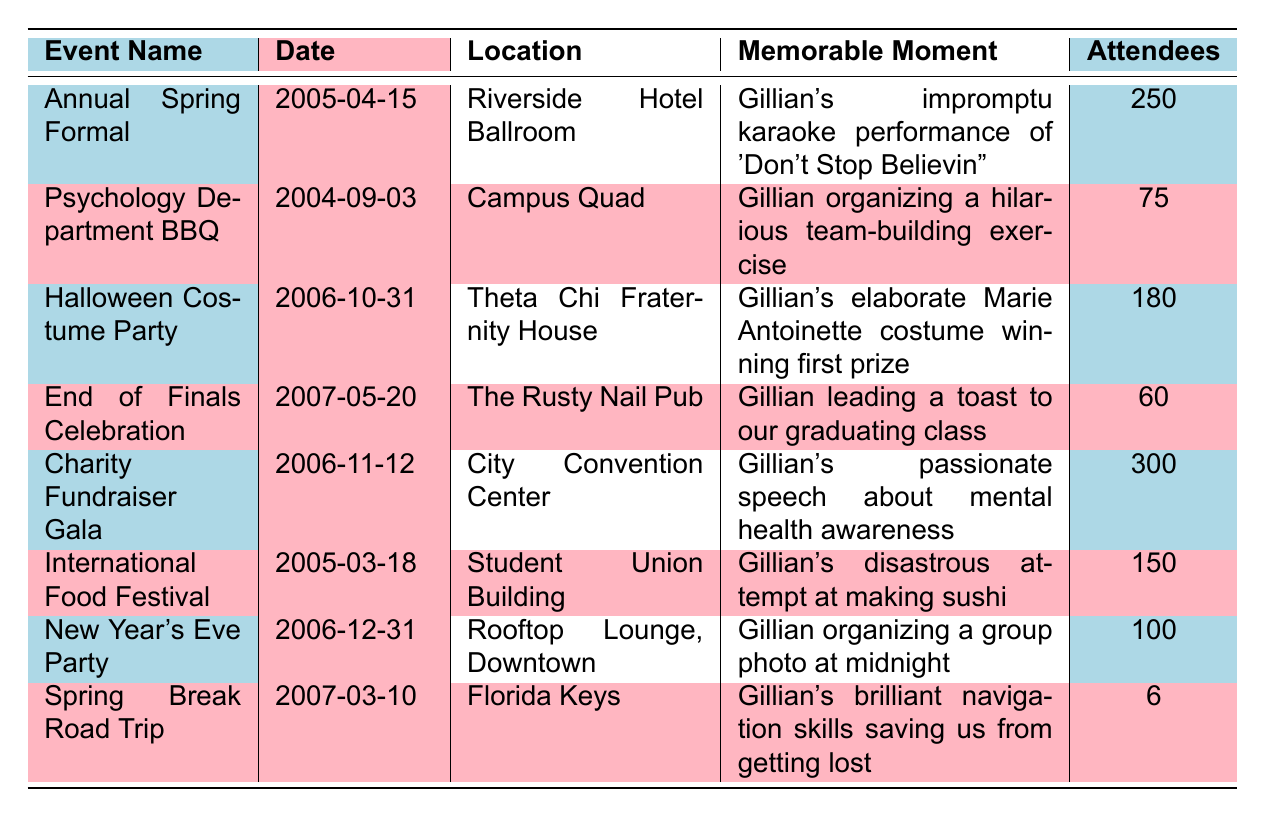What was the date of the Annual Spring Formal? The table lists the date of the Annual Spring Formal as April 15, 2005.
Answer: April 15, 2005 How many attendees were there at the Charity Fundraiser Gala? The table shows that the Charity Fundraiser Gala had 300 attendees.
Answer: 300 Which event had the least number of attendees? By comparing the attendee numbers in the table, the Spring Break Road Trip had only 6 attendees, which is the least.
Answer: Spring Break Road Trip What was the memorable moment at the Halloween Costume Party? According to the table, the memorable moment was Gillian's elaborate Marie Antoinette costume winning first prize.
Answer: Gillian's elaborate Marie Antoinette costume winning first prize How many attendees were there in total across all events? To find the total, sum the attendees: 250 + 75 + 180 + 60 + 300 + 150 + 100 + 6 = 1121.
Answer: 1121 Did Gillian participate in any events that had more than 200 attendees? Yes, the Charity Fundraiser Gala had 300 attendees, which is more than 200.
Answer: Yes What was Gillian's role at the End of Finals Celebration? The table indicates that Gillian was leading a toast to the graduating class, indicating her role was celebratory and leadership.
Answer: Leading a toast In what location did Gillian win first prize for her costume? The table specifies that Gillian won first prize at the Halloween Costume Party, which took place at the Theta Chi Fraternity House.
Answer: Theta Chi Fraternity House What is the average number of attendees across all events? To find the average, sum the attendees (1121) and divide by the number of events (8). So, 1121 / 8 = 140.125.
Answer: 140.125 Was there a memorable moment related to cooking at any of the events? Yes, at the International Food Festival, Gillian's attempt at making sushi was noted as disastrous, making it a memorable cooking moment.
Answer: Yes Which event took place on New Year's Eve? The table indicates that the New Year's Eve Party occurred on December 31, 2006.
Answer: December 31, 2006 